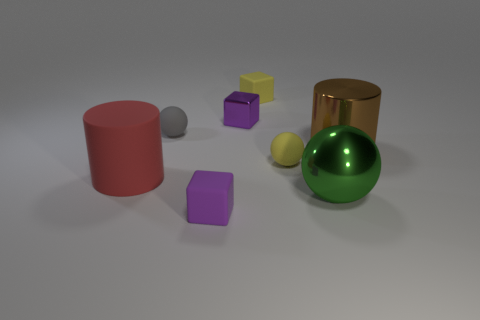How many big shiny balls have the same color as the shiny cylinder? There are no big shiny balls that share the same color as the shiny cylinder in the image. The shiny cylinder appears to be gold, and there is only one big shiny ball, which is green. 